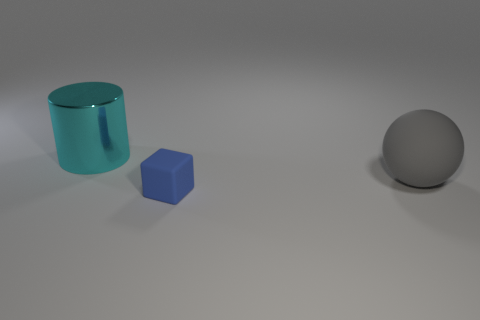Add 1 big gray cylinders. How many objects exist? 4 Subtract all cylinders. How many objects are left? 2 Subtract 0 red cylinders. How many objects are left? 3 Subtract all tiny purple things. Subtract all blue rubber things. How many objects are left? 2 Add 1 gray spheres. How many gray spheres are left? 2 Add 1 small purple balls. How many small purple balls exist? 1 